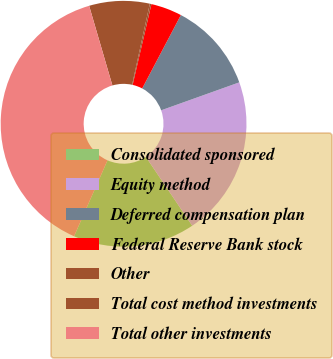<chart> <loc_0><loc_0><loc_500><loc_500><pie_chart><fcel>Consolidated sponsored<fcel>Equity method<fcel>Deferred compensation plan<fcel>Federal Reserve Bank stock<fcel>Other<fcel>Total cost method investments<fcel>Total other investments<nl><fcel>16.03%<fcel>21.04%<fcel>11.81%<fcel>4.08%<fcel>0.21%<fcel>7.95%<fcel>38.88%<nl></chart> 